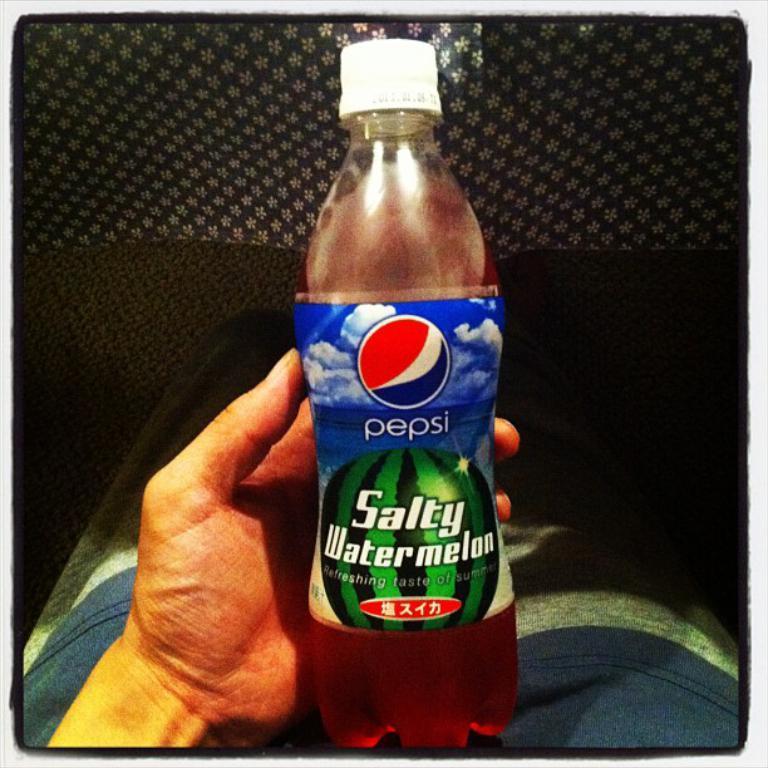How would you summarize this image in a sentence or two? a person is holding a bottle in his hand on which pepsi salty watermelon is written. 